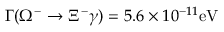Convert formula to latex. <formula><loc_0><loc_0><loc_500><loc_500>\Gamma ( \Omega ^ { - } \rightarrow \Xi ^ { - } \gamma ) = 5 . 6 \times 1 0 ^ { - 1 1 } e V</formula> 